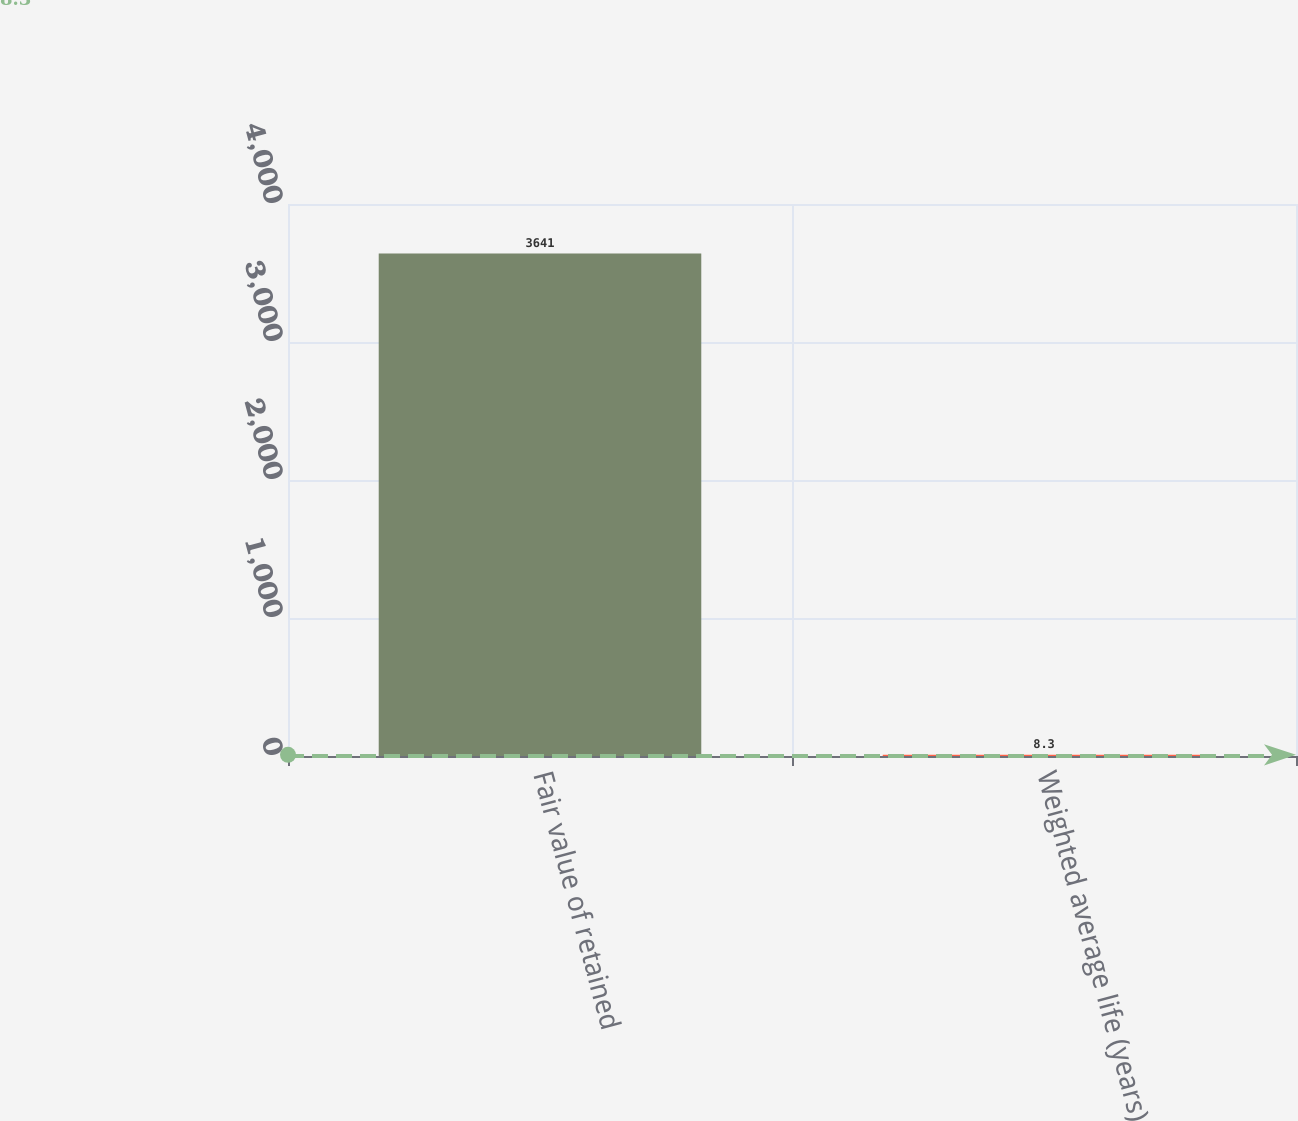<chart> <loc_0><loc_0><loc_500><loc_500><bar_chart><fcel>Fair value of retained<fcel>Weighted average life (years)<nl><fcel>3641<fcel>8.3<nl></chart> 